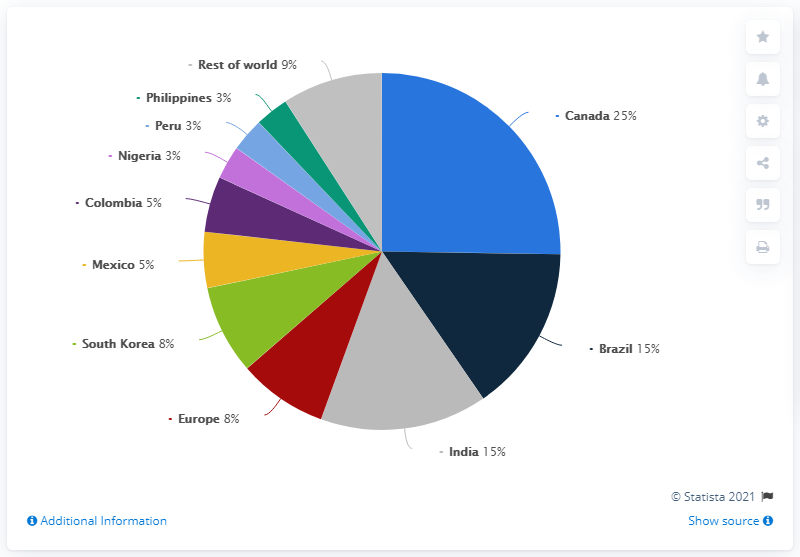Identify some key points in this picture. In 2020, the United States exported 15% of its total ethanol production to Brazil, which was the top destination for U.S. ethanol exports that year. Canada received 25% of ethanol exports in 2020, making it the top export destination for ethanol that year. Europe is significantly smaller than India. There are countries that have a share of 3%. 